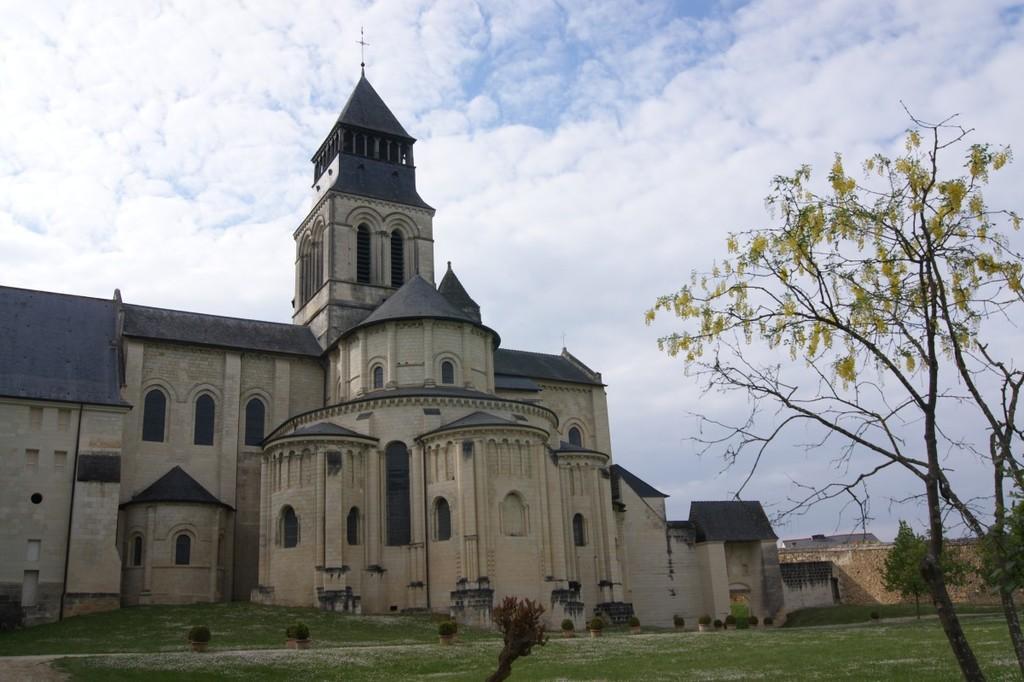Can you describe this image briefly? In this image we can see a building with a group of windows on it. In the background, we can see a group of trees and a cloudy sky. 